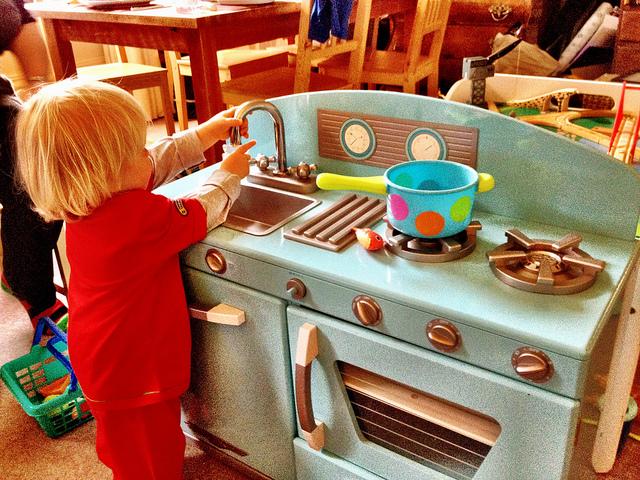What color is the toy kitchen?
Answer briefly. Blue. Is this a real kitchen?
Answer briefly. No. What is the child doing?
Answer briefly. Playing. 